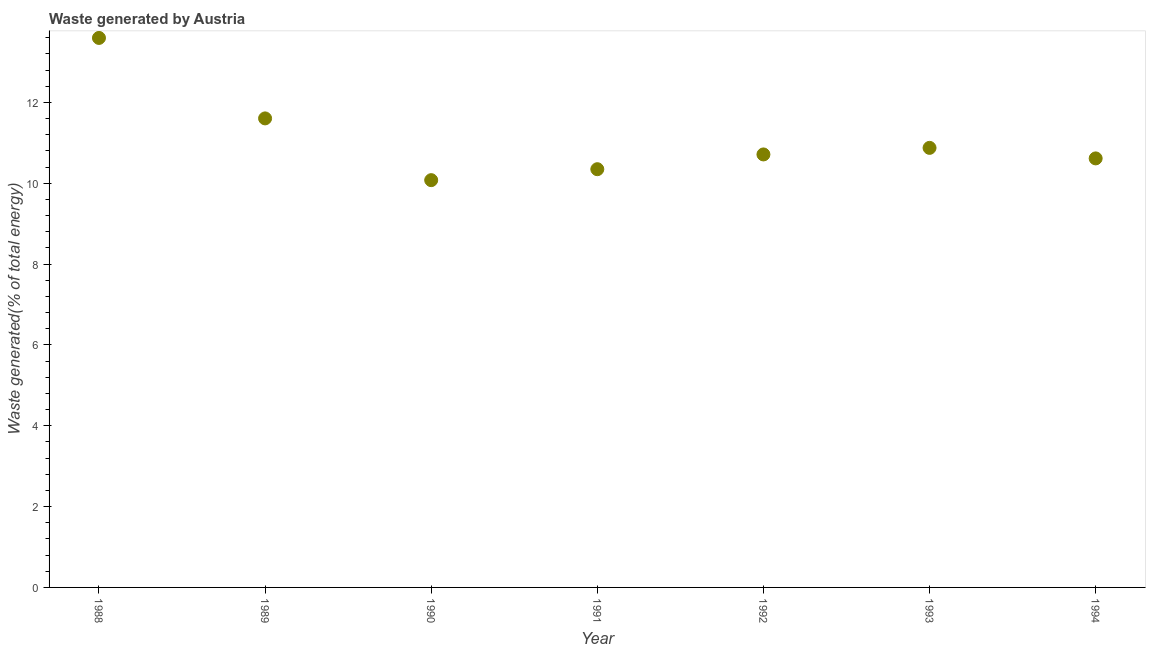What is the amount of waste generated in 1989?
Offer a terse response. 11.61. Across all years, what is the maximum amount of waste generated?
Keep it short and to the point. 13.6. Across all years, what is the minimum amount of waste generated?
Ensure brevity in your answer.  10.08. In which year was the amount of waste generated maximum?
Make the answer very short. 1988. What is the sum of the amount of waste generated?
Your answer should be compact. 77.84. What is the difference between the amount of waste generated in 1989 and 1994?
Offer a terse response. 0.99. What is the average amount of waste generated per year?
Keep it short and to the point. 11.12. What is the median amount of waste generated?
Provide a short and direct response. 10.71. In how many years, is the amount of waste generated greater than 4.8 %?
Your answer should be compact. 7. Do a majority of the years between 1988 and 1989 (inclusive) have amount of waste generated greater than 8.4 %?
Provide a succinct answer. Yes. What is the ratio of the amount of waste generated in 1991 to that in 1993?
Provide a succinct answer. 0.95. Is the amount of waste generated in 1988 less than that in 1992?
Your answer should be very brief. No. Is the difference between the amount of waste generated in 1991 and 1992 greater than the difference between any two years?
Offer a terse response. No. What is the difference between the highest and the second highest amount of waste generated?
Offer a very short reply. 1.99. What is the difference between the highest and the lowest amount of waste generated?
Give a very brief answer. 3.52. How many dotlines are there?
Offer a very short reply. 1. How many years are there in the graph?
Your answer should be very brief. 7. What is the difference between two consecutive major ticks on the Y-axis?
Make the answer very short. 2. Does the graph contain any zero values?
Make the answer very short. No. What is the title of the graph?
Your answer should be very brief. Waste generated by Austria. What is the label or title of the X-axis?
Offer a very short reply. Year. What is the label or title of the Y-axis?
Give a very brief answer. Waste generated(% of total energy). What is the Waste generated(% of total energy) in 1988?
Give a very brief answer. 13.6. What is the Waste generated(% of total energy) in 1989?
Offer a terse response. 11.61. What is the Waste generated(% of total energy) in 1990?
Offer a terse response. 10.08. What is the Waste generated(% of total energy) in 1991?
Ensure brevity in your answer.  10.35. What is the Waste generated(% of total energy) in 1992?
Offer a very short reply. 10.71. What is the Waste generated(% of total energy) in 1993?
Your response must be concise. 10.88. What is the Waste generated(% of total energy) in 1994?
Your answer should be very brief. 10.62. What is the difference between the Waste generated(% of total energy) in 1988 and 1989?
Offer a very short reply. 1.99. What is the difference between the Waste generated(% of total energy) in 1988 and 1990?
Offer a terse response. 3.52. What is the difference between the Waste generated(% of total energy) in 1988 and 1991?
Offer a terse response. 3.25. What is the difference between the Waste generated(% of total energy) in 1988 and 1992?
Your answer should be very brief. 2.88. What is the difference between the Waste generated(% of total energy) in 1988 and 1993?
Provide a short and direct response. 2.72. What is the difference between the Waste generated(% of total energy) in 1988 and 1994?
Provide a succinct answer. 2.98. What is the difference between the Waste generated(% of total energy) in 1989 and 1990?
Offer a terse response. 1.53. What is the difference between the Waste generated(% of total energy) in 1989 and 1991?
Make the answer very short. 1.26. What is the difference between the Waste generated(% of total energy) in 1989 and 1992?
Offer a terse response. 0.89. What is the difference between the Waste generated(% of total energy) in 1989 and 1993?
Your answer should be compact. 0.73. What is the difference between the Waste generated(% of total energy) in 1989 and 1994?
Provide a succinct answer. 0.99. What is the difference between the Waste generated(% of total energy) in 1990 and 1991?
Your answer should be very brief. -0.27. What is the difference between the Waste generated(% of total energy) in 1990 and 1992?
Keep it short and to the point. -0.64. What is the difference between the Waste generated(% of total energy) in 1990 and 1993?
Make the answer very short. -0.8. What is the difference between the Waste generated(% of total energy) in 1990 and 1994?
Offer a very short reply. -0.54. What is the difference between the Waste generated(% of total energy) in 1991 and 1992?
Your response must be concise. -0.37. What is the difference between the Waste generated(% of total energy) in 1991 and 1993?
Offer a terse response. -0.53. What is the difference between the Waste generated(% of total energy) in 1991 and 1994?
Offer a very short reply. -0.27. What is the difference between the Waste generated(% of total energy) in 1992 and 1993?
Provide a succinct answer. -0.16. What is the difference between the Waste generated(% of total energy) in 1992 and 1994?
Give a very brief answer. 0.1. What is the difference between the Waste generated(% of total energy) in 1993 and 1994?
Your answer should be compact. 0.26. What is the ratio of the Waste generated(% of total energy) in 1988 to that in 1989?
Give a very brief answer. 1.17. What is the ratio of the Waste generated(% of total energy) in 1988 to that in 1990?
Your answer should be very brief. 1.35. What is the ratio of the Waste generated(% of total energy) in 1988 to that in 1991?
Provide a short and direct response. 1.31. What is the ratio of the Waste generated(% of total energy) in 1988 to that in 1992?
Your answer should be compact. 1.27. What is the ratio of the Waste generated(% of total energy) in 1988 to that in 1993?
Your answer should be compact. 1.25. What is the ratio of the Waste generated(% of total energy) in 1988 to that in 1994?
Keep it short and to the point. 1.28. What is the ratio of the Waste generated(% of total energy) in 1989 to that in 1990?
Offer a terse response. 1.15. What is the ratio of the Waste generated(% of total energy) in 1989 to that in 1991?
Keep it short and to the point. 1.12. What is the ratio of the Waste generated(% of total energy) in 1989 to that in 1992?
Offer a very short reply. 1.08. What is the ratio of the Waste generated(% of total energy) in 1989 to that in 1993?
Provide a succinct answer. 1.07. What is the ratio of the Waste generated(% of total energy) in 1989 to that in 1994?
Your answer should be compact. 1.09. What is the ratio of the Waste generated(% of total energy) in 1990 to that in 1991?
Offer a terse response. 0.97. What is the ratio of the Waste generated(% of total energy) in 1990 to that in 1992?
Provide a succinct answer. 0.94. What is the ratio of the Waste generated(% of total energy) in 1990 to that in 1993?
Provide a succinct answer. 0.93. What is the ratio of the Waste generated(% of total energy) in 1990 to that in 1994?
Ensure brevity in your answer.  0.95. What is the ratio of the Waste generated(% of total energy) in 1991 to that in 1993?
Provide a short and direct response. 0.95. What is the ratio of the Waste generated(% of total energy) in 1991 to that in 1994?
Your answer should be compact. 0.97. What is the ratio of the Waste generated(% of total energy) in 1992 to that in 1994?
Your answer should be very brief. 1.01. What is the ratio of the Waste generated(% of total energy) in 1993 to that in 1994?
Your answer should be compact. 1.02. 